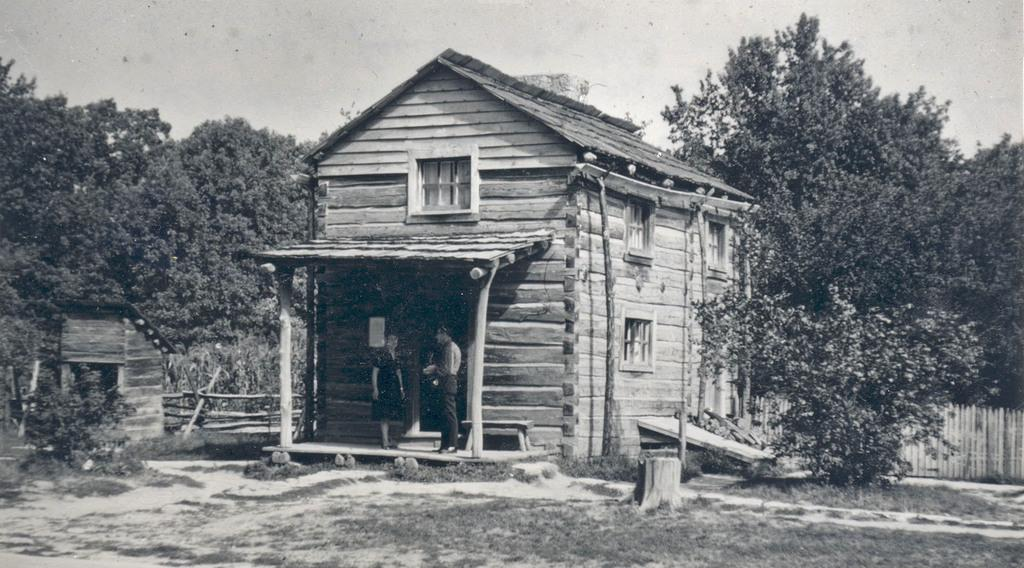What is the color scheme of the image? The image is black and white. How many people are in the image? There are two persons in the image. What type of structures can be seen in the image? There are houses in the image. What type of vegetation is present in the image? There are plants and trees in the image. What architectural feature can be seen in the image? There is a fence in the image. What is visible in the background of the image? The sky is visible in the background of the image. How many children are playing on the beam in the image? There is no beam or children present in the image. 